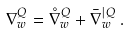Convert formula to latex. <formula><loc_0><loc_0><loc_500><loc_500>\nabla _ { w } ^ { Q } = \mathring { \nabla } ^ { Q } _ { w } + \bar { \nabla } ^ { | Q } _ { w } \, .</formula> 